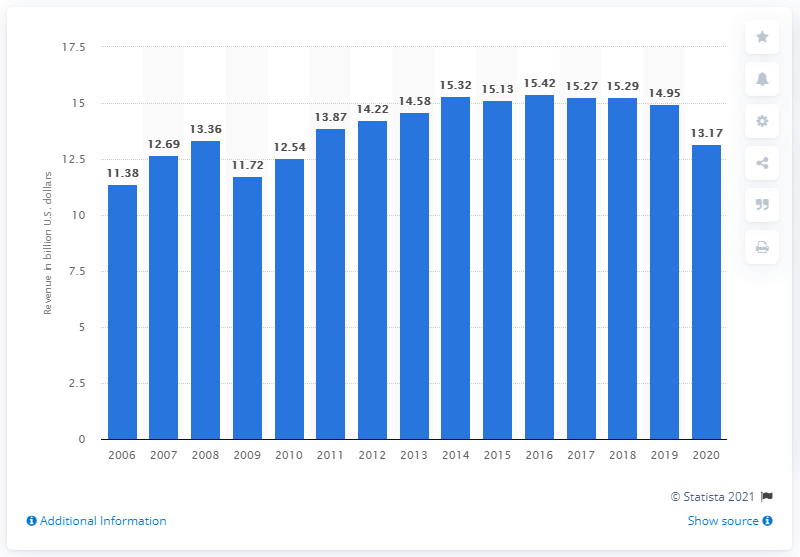List a handful of essential elements in this visual. In 2020, Omnicom Group's global revenue was 13.17... 